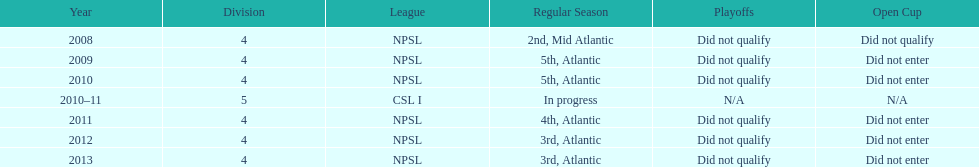What is the lowest place they came in 5th. 